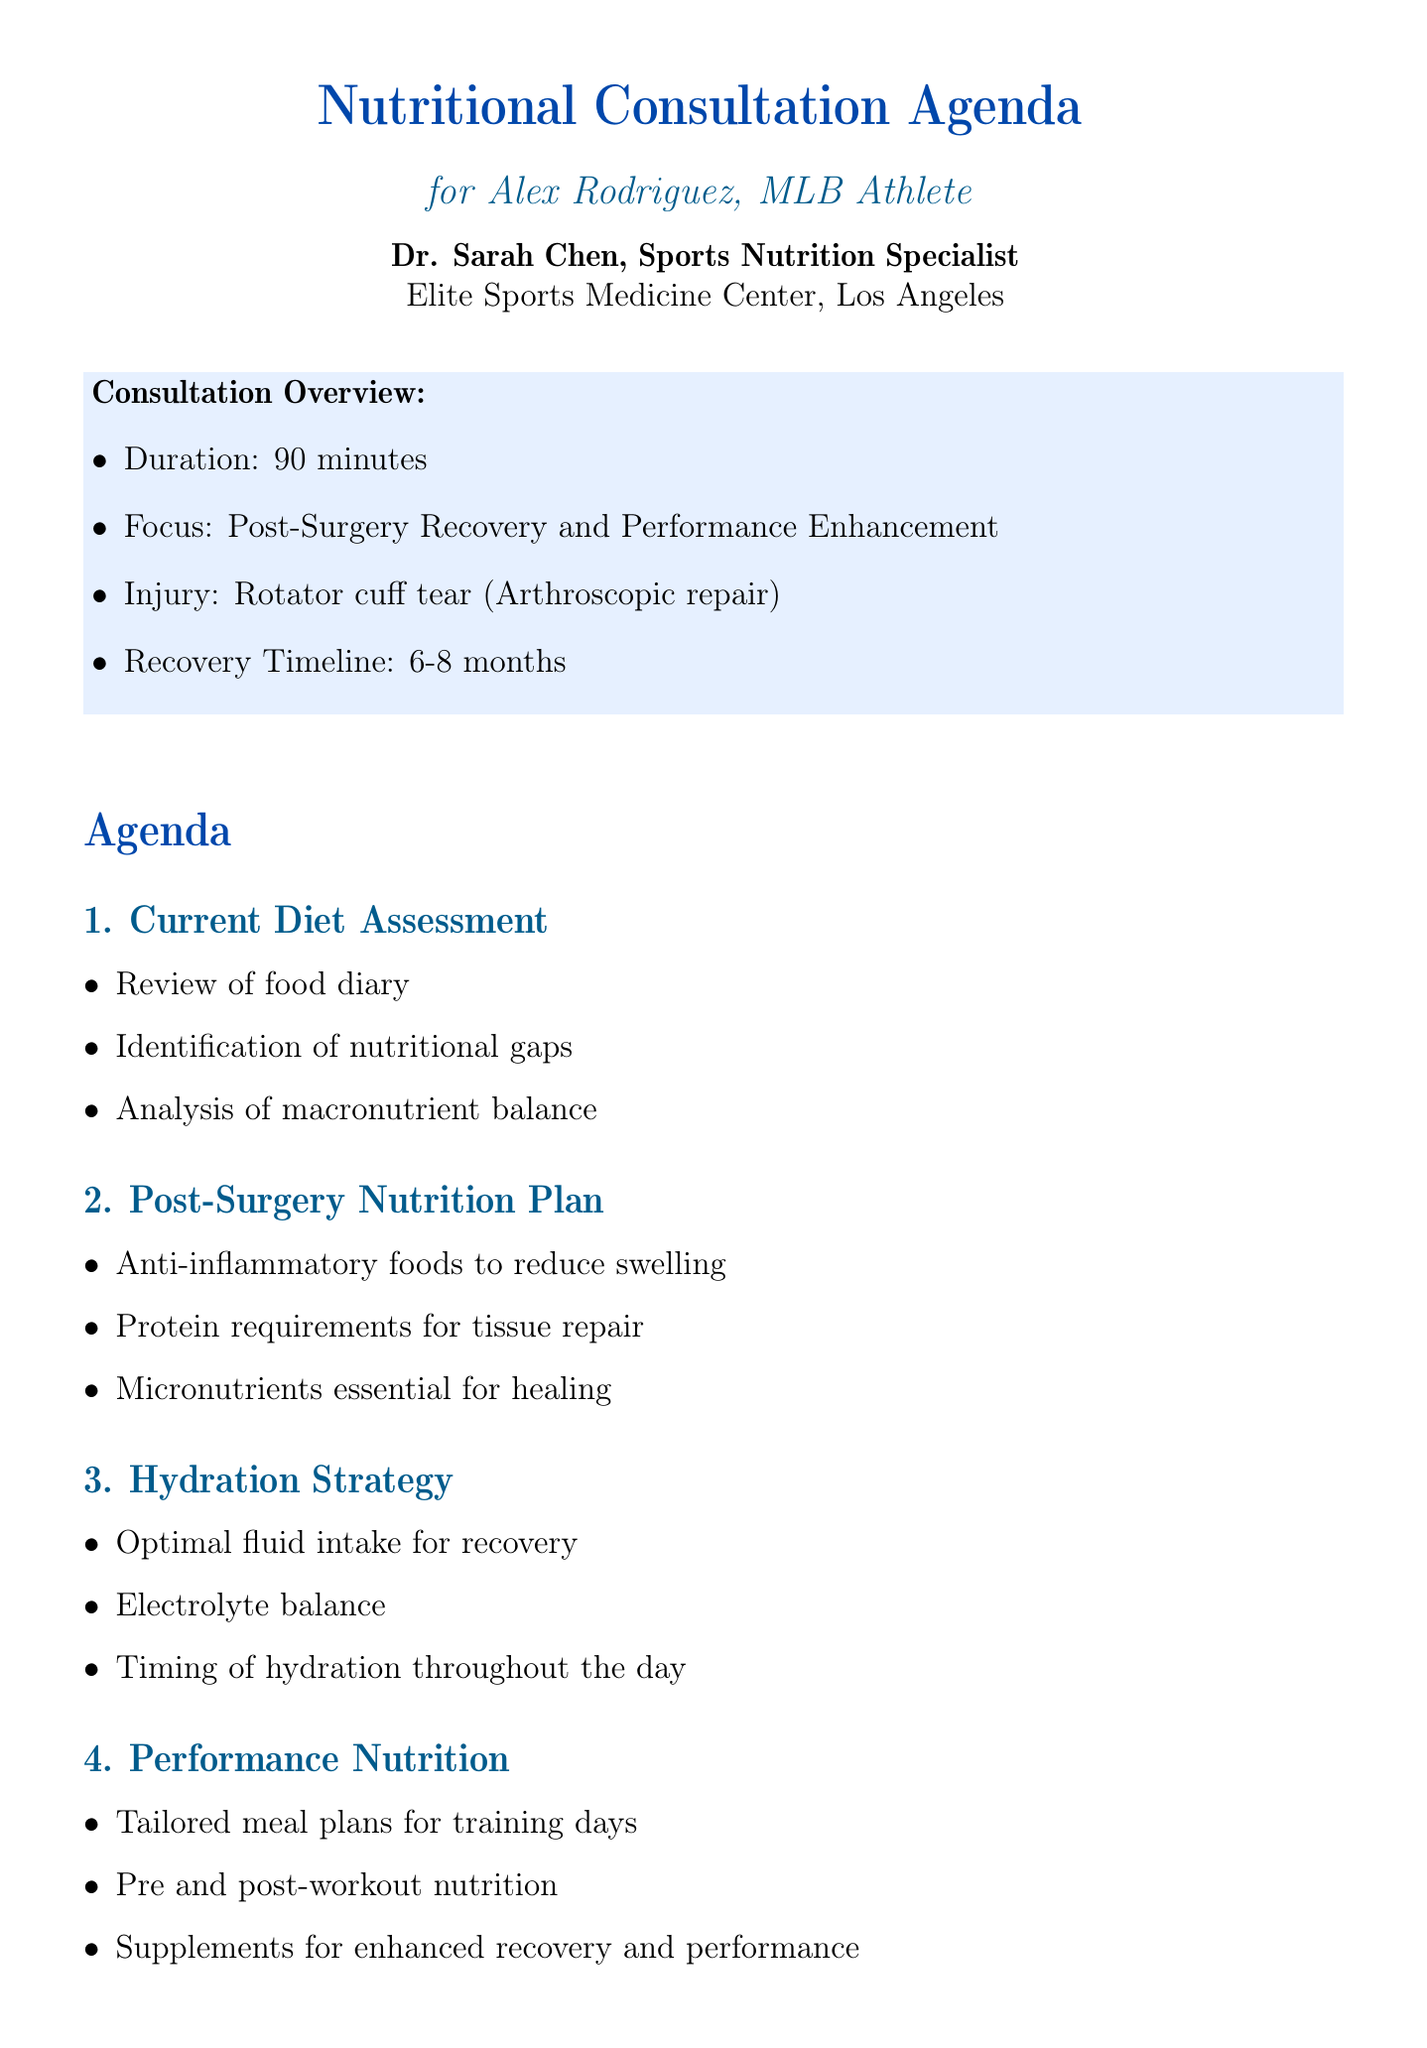What is the title of the consultation? The title of the consultation is stated at the beginning of the agenda.
Answer: Nutritional Consultation for Post-Surgery Recovery and Performance Enhancement Who is the nutritionist? The document lists the nutritionist's name in the overview section.
Answer: Dr. Sarah Chen What is the location of the consultation? The consultation location is provided in the header.
Answer: Elite Sports Medicine Center, Los Angeles What is the duration of the consultation? Duration is mentioned under the consultation overview section.
Answer: 90 minutes What is the recovery timeline after surgery? The recovery timeline is included in the overview of the document.
Answer: 6-8 months What are the essential micronutrients for healing discussed? The document lists essential micronutrients under the post-surgery nutrition plan.
Answer: Vitamin C, Zinc, Vitamin D How often are regular check-ins planned? The frequency of regular check-ins is noted in the follow-up plan.
Answer: Monthly during recovery period What is the purpose of the recommended supplement "Thorne Research Meriva-SR Curcumin Phytosome"? The purpose of the supplement is specified in the recommendations section.
Answer: Natural anti-inflammatory support What type of resource is "MyFitnessPal"? The type of resource is stated in the additional resources section.
Answer: Mobile App 